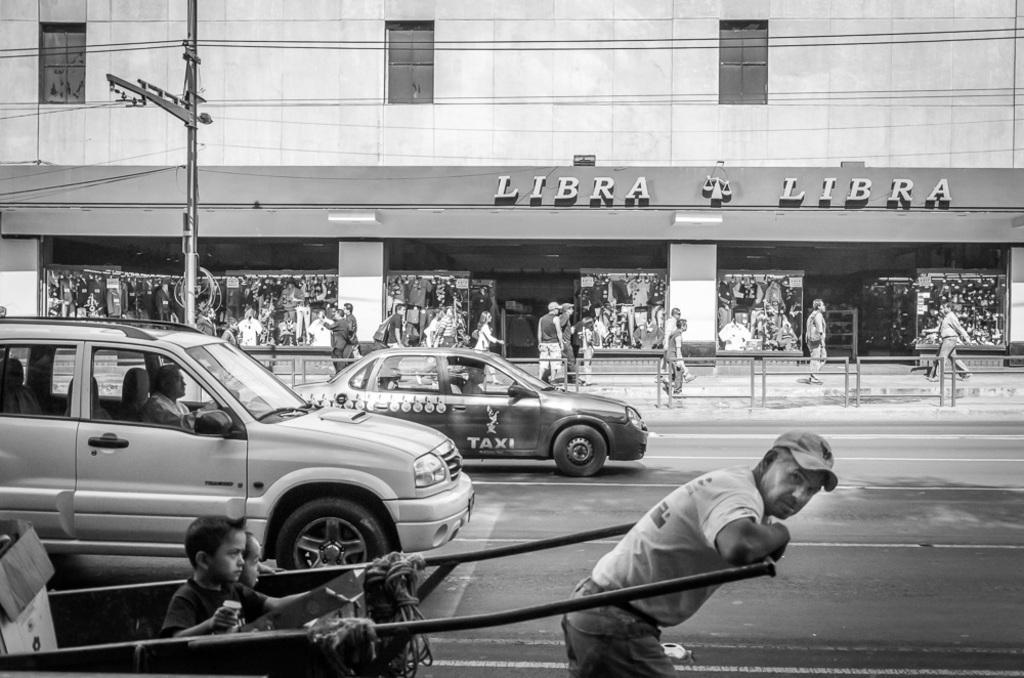How would you summarize this image in a sentence or two? This is a black and white picture. This is a building with windows. These are stores. Here we can see persons walking on the road. We can see vehicles and a man pulling a cart with his hands and kids are sitting in a cart. 